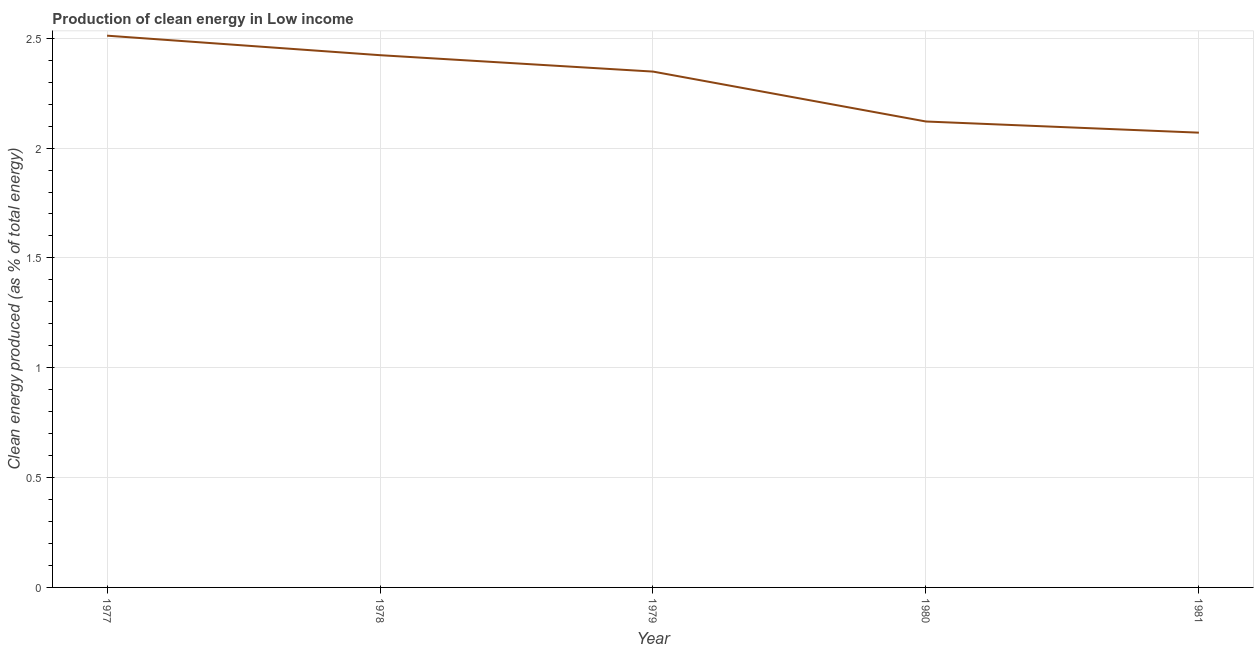What is the production of clean energy in 1978?
Give a very brief answer. 2.42. Across all years, what is the maximum production of clean energy?
Offer a terse response. 2.51. Across all years, what is the minimum production of clean energy?
Ensure brevity in your answer.  2.07. What is the sum of the production of clean energy?
Provide a succinct answer. 11.47. What is the difference between the production of clean energy in 1977 and 1978?
Your answer should be compact. 0.09. What is the average production of clean energy per year?
Your answer should be very brief. 2.29. What is the median production of clean energy?
Ensure brevity in your answer.  2.35. What is the ratio of the production of clean energy in 1977 to that in 1978?
Provide a short and direct response. 1.04. Is the production of clean energy in 1980 less than that in 1981?
Your answer should be compact. No. What is the difference between the highest and the second highest production of clean energy?
Give a very brief answer. 0.09. Is the sum of the production of clean energy in 1977 and 1981 greater than the maximum production of clean energy across all years?
Keep it short and to the point. Yes. What is the difference between the highest and the lowest production of clean energy?
Provide a short and direct response. 0.44. Does the production of clean energy monotonically increase over the years?
Your response must be concise. No. How many lines are there?
Give a very brief answer. 1. How many years are there in the graph?
Your answer should be very brief. 5. What is the difference between two consecutive major ticks on the Y-axis?
Ensure brevity in your answer.  0.5. Does the graph contain any zero values?
Your answer should be compact. No. What is the title of the graph?
Offer a terse response. Production of clean energy in Low income. What is the label or title of the Y-axis?
Your answer should be very brief. Clean energy produced (as % of total energy). What is the Clean energy produced (as % of total energy) of 1977?
Offer a terse response. 2.51. What is the Clean energy produced (as % of total energy) in 1978?
Give a very brief answer. 2.42. What is the Clean energy produced (as % of total energy) in 1979?
Keep it short and to the point. 2.35. What is the Clean energy produced (as % of total energy) of 1980?
Ensure brevity in your answer.  2.12. What is the Clean energy produced (as % of total energy) of 1981?
Your response must be concise. 2.07. What is the difference between the Clean energy produced (as % of total energy) in 1977 and 1978?
Keep it short and to the point. 0.09. What is the difference between the Clean energy produced (as % of total energy) in 1977 and 1979?
Provide a short and direct response. 0.16. What is the difference between the Clean energy produced (as % of total energy) in 1977 and 1980?
Offer a terse response. 0.39. What is the difference between the Clean energy produced (as % of total energy) in 1977 and 1981?
Your response must be concise. 0.44. What is the difference between the Clean energy produced (as % of total energy) in 1978 and 1979?
Your response must be concise. 0.07. What is the difference between the Clean energy produced (as % of total energy) in 1978 and 1980?
Provide a short and direct response. 0.3. What is the difference between the Clean energy produced (as % of total energy) in 1978 and 1981?
Your answer should be compact. 0.35. What is the difference between the Clean energy produced (as % of total energy) in 1979 and 1980?
Provide a short and direct response. 0.23. What is the difference between the Clean energy produced (as % of total energy) in 1979 and 1981?
Give a very brief answer. 0.28. What is the difference between the Clean energy produced (as % of total energy) in 1980 and 1981?
Provide a short and direct response. 0.05. What is the ratio of the Clean energy produced (as % of total energy) in 1977 to that in 1979?
Make the answer very short. 1.07. What is the ratio of the Clean energy produced (as % of total energy) in 1977 to that in 1980?
Your response must be concise. 1.18. What is the ratio of the Clean energy produced (as % of total energy) in 1977 to that in 1981?
Provide a succinct answer. 1.21. What is the ratio of the Clean energy produced (as % of total energy) in 1978 to that in 1979?
Your answer should be very brief. 1.03. What is the ratio of the Clean energy produced (as % of total energy) in 1978 to that in 1980?
Provide a short and direct response. 1.14. What is the ratio of the Clean energy produced (as % of total energy) in 1978 to that in 1981?
Provide a short and direct response. 1.17. What is the ratio of the Clean energy produced (as % of total energy) in 1979 to that in 1980?
Make the answer very short. 1.11. What is the ratio of the Clean energy produced (as % of total energy) in 1979 to that in 1981?
Provide a succinct answer. 1.13. 